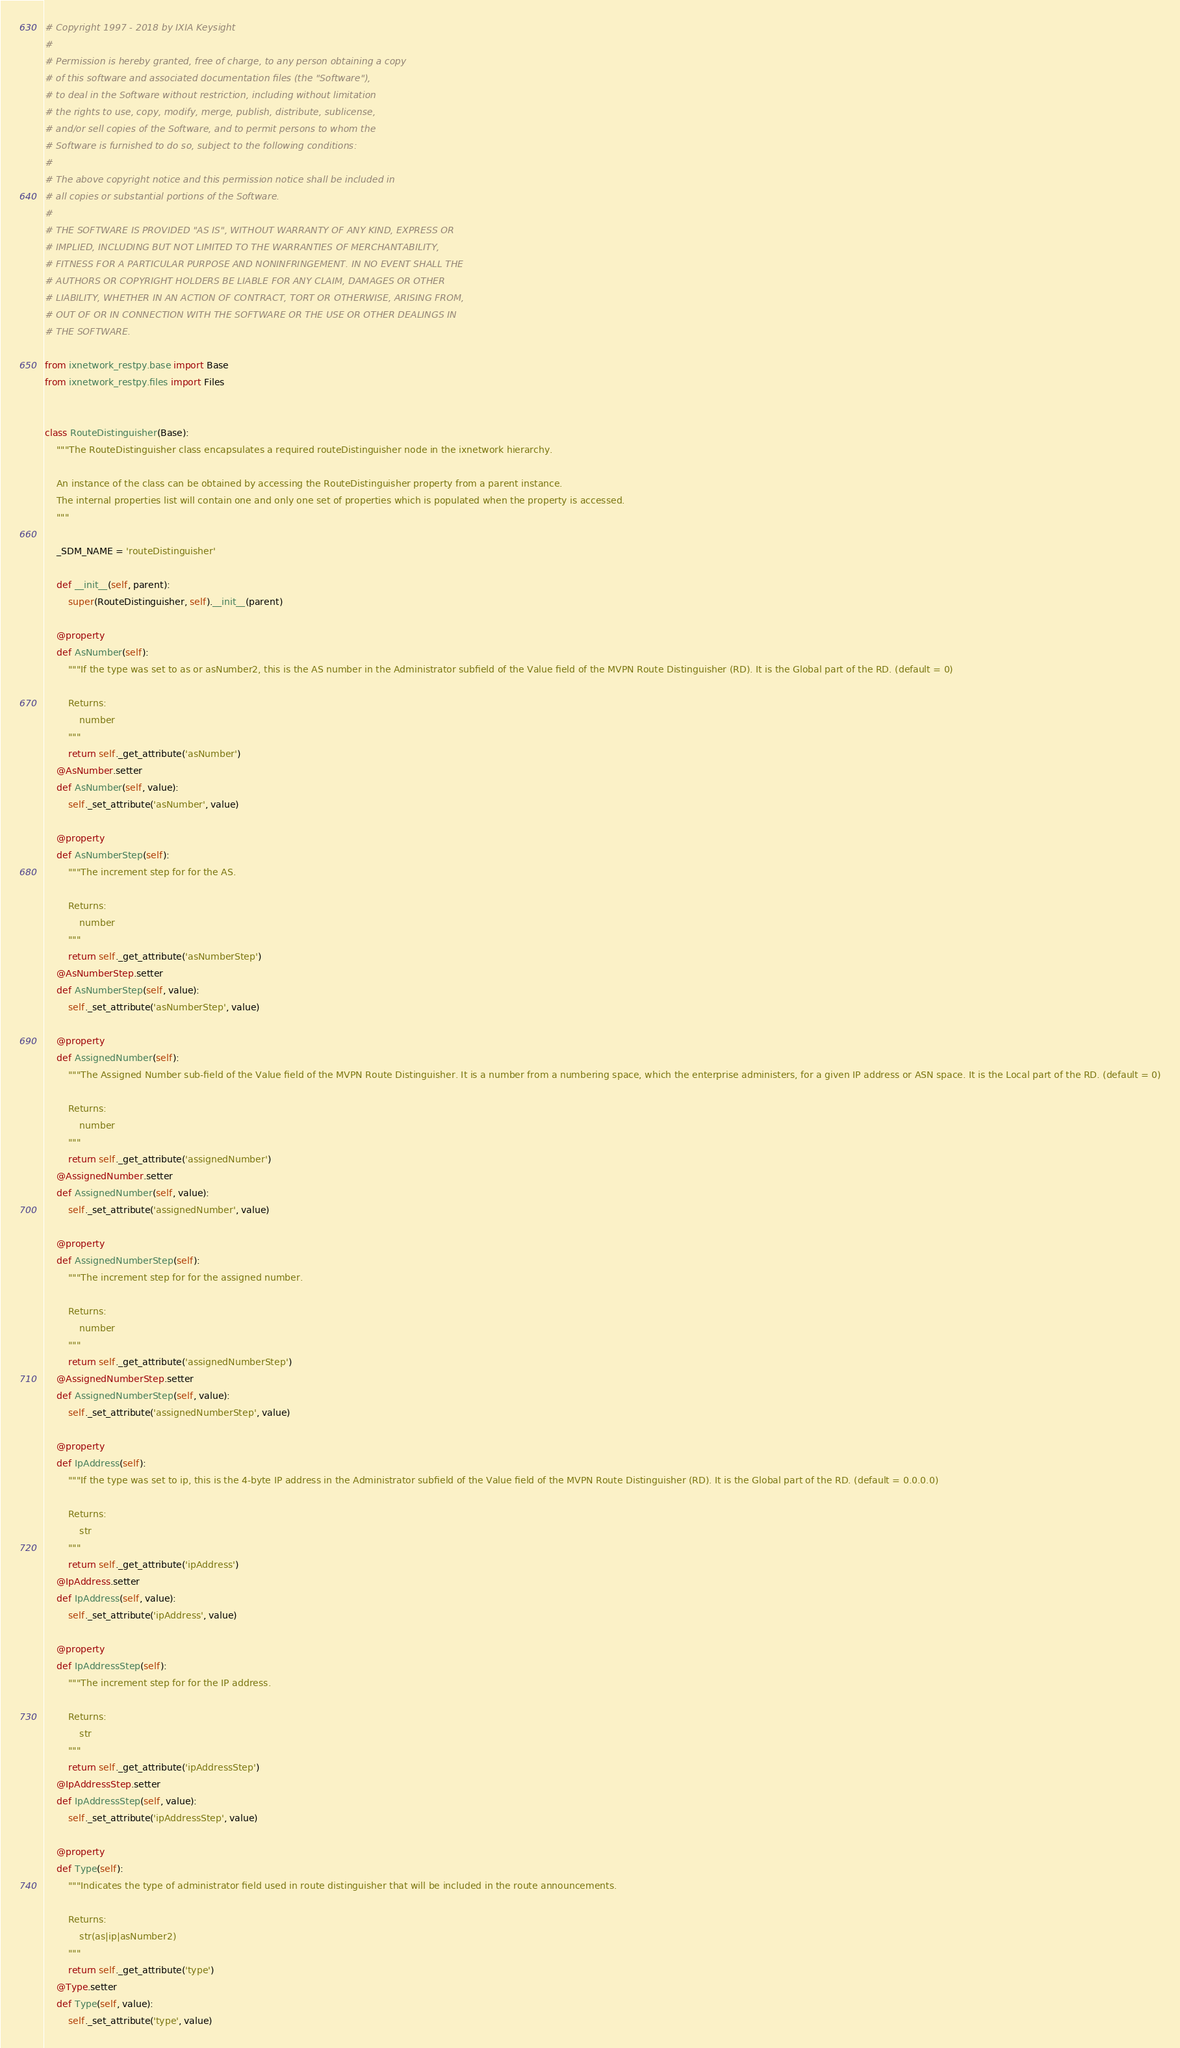Convert code to text. <code><loc_0><loc_0><loc_500><loc_500><_Python_>
# Copyright 1997 - 2018 by IXIA Keysight
#
# Permission is hereby granted, free of charge, to any person obtaining a copy
# of this software and associated documentation files (the "Software"),
# to deal in the Software without restriction, including without limitation
# the rights to use, copy, modify, merge, publish, distribute, sublicense,
# and/or sell copies of the Software, and to permit persons to whom the
# Software is furnished to do so, subject to the following conditions:
#
# The above copyright notice and this permission notice shall be included in
# all copies or substantial portions of the Software.
#
# THE SOFTWARE IS PROVIDED "AS IS", WITHOUT WARRANTY OF ANY KIND, EXPRESS OR
# IMPLIED, INCLUDING BUT NOT LIMITED TO THE WARRANTIES OF MERCHANTABILITY,
# FITNESS FOR A PARTICULAR PURPOSE AND NONINFRINGEMENT. IN NO EVENT SHALL THE
# AUTHORS OR COPYRIGHT HOLDERS BE LIABLE FOR ANY CLAIM, DAMAGES OR OTHER
# LIABILITY, WHETHER IN AN ACTION OF CONTRACT, TORT OR OTHERWISE, ARISING FROM,
# OUT OF OR IN CONNECTION WITH THE SOFTWARE OR THE USE OR OTHER DEALINGS IN
# THE SOFTWARE.
    
from ixnetwork_restpy.base import Base
from ixnetwork_restpy.files import Files


class RouteDistinguisher(Base):
	"""The RouteDistinguisher class encapsulates a required routeDistinguisher node in the ixnetwork hierarchy.

	An instance of the class can be obtained by accessing the RouteDistinguisher property from a parent instance.
	The internal properties list will contain one and only one set of properties which is populated when the property is accessed.
	"""

	_SDM_NAME = 'routeDistinguisher'

	def __init__(self, parent):
		super(RouteDistinguisher, self).__init__(parent)

	@property
	def AsNumber(self):
		"""If the type was set to as or asNumber2, this is the AS number in the Administrator subfield of the Value field of the MVPN Route Distinguisher (RD). It is the Global part of the RD. (default = 0)

		Returns:
			number
		"""
		return self._get_attribute('asNumber')
	@AsNumber.setter
	def AsNumber(self, value):
		self._set_attribute('asNumber', value)

	@property
	def AsNumberStep(self):
		"""The increment step for for the AS.

		Returns:
			number
		"""
		return self._get_attribute('asNumberStep')
	@AsNumberStep.setter
	def AsNumberStep(self, value):
		self._set_attribute('asNumberStep', value)

	@property
	def AssignedNumber(self):
		"""The Assigned Number sub-field of the Value field of the MVPN Route Distinguisher. It is a number from a numbering space, which the enterprise administers, for a given IP address or ASN space. It is the Local part of the RD. (default = 0)

		Returns:
			number
		"""
		return self._get_attribute('assignedNumber')
	@AssignedNumber.setter
	def AssignedNumber(self, value):
		self._set_attribute('assignedNumber', value)

	@property
	def AssignedNumberStep(self):
		"""The increment step for for the assigned number.

		Returns:
			number
		"""
		return self._get_attribute('assignedNumberStep')
	@AssignedNumberStep.setter
	def AssignedNumberStep(self, value):
		self._set_attribute('assignedNumberStep', value)

	@property
	def IpAddress(self):
		"""If the type was set to ip, this is the 4-byte IP address in the Administrator subfield of the Value field of the MVPN Route Distinguisher (RD). It is the Global part of the RD. (default = 0.0.0.0)

		Returns:
			str
		"""
		return self._get_attribute('ipAddress')
	@IpAddress.setter
	def IpAddress(self, value):
		self._set_attribute('ipAddress', value)

	@property
	def IpAddressStep(self):
		"""The increment step for for the IP address.

		Returns:
			str
		"""
		return self._get_attribute('ipAddressStep')
	@IpAddressStep.setter
	def IpAddressStep(self, value):
		self._set_attribute('ipAddressStep', value)

	@property
	def Type(self):
		"""Indicates the type of administrator field used in route distinguisher that will be included in the route announcements.

		Returns:
			str(as|ip|asNumber2)
		"""
		return self._get_attribute('type')
	@Type.setter
	def Type(self, value):
		self._set_attribute('type', value)
</code> 